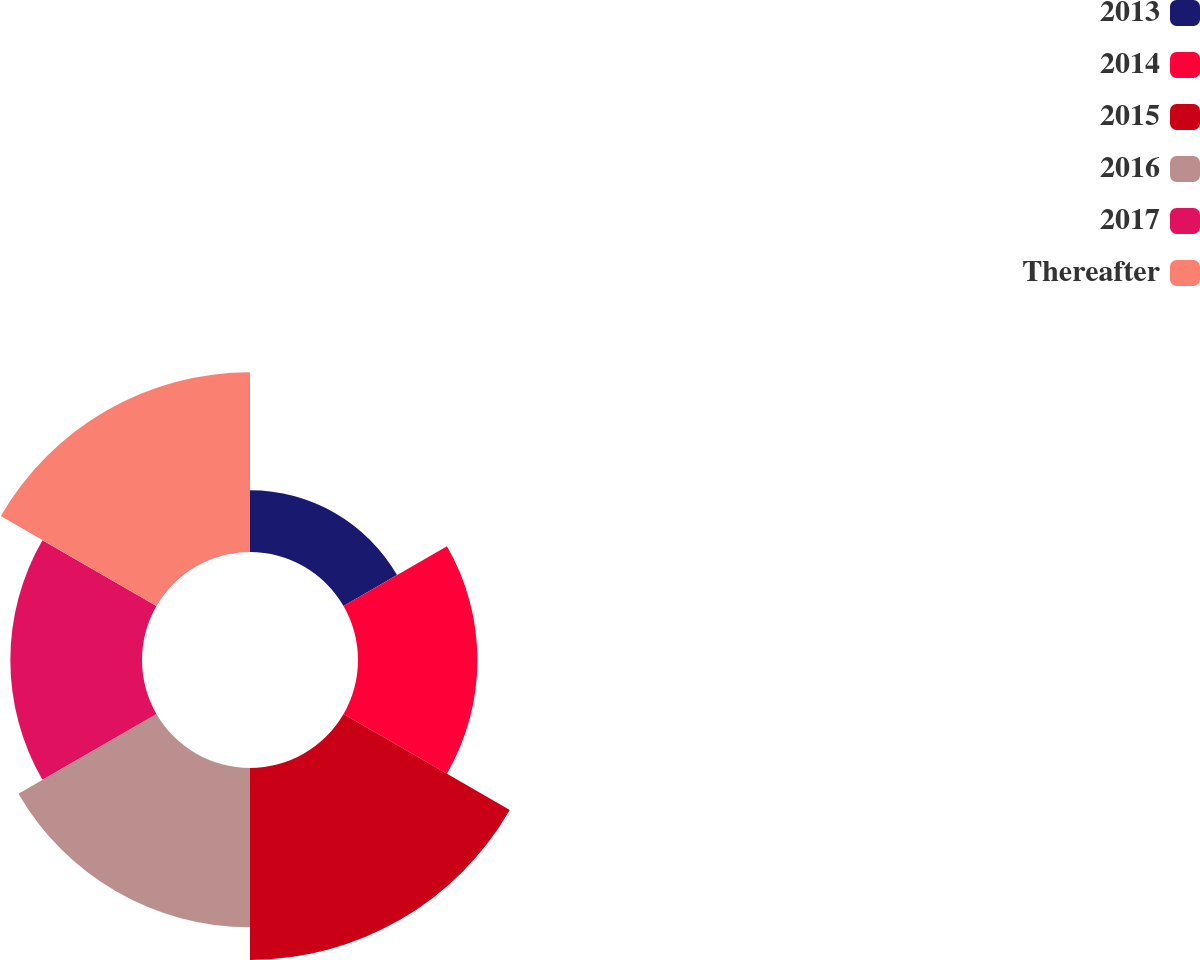Convert chart. <chart><loc_0><loc_0><loc_500><loc_500><pie_chart><fcel>2013<fcel>2014<fcel>2015<fcel>2016<fcel>2017<fcel>Thereafter<nl><fcel>7.32%<fcel>14.15%<fcel>22.75%<fcel>18.88%<fcel>15.6%<fcel>21.3%<nl></chart> 